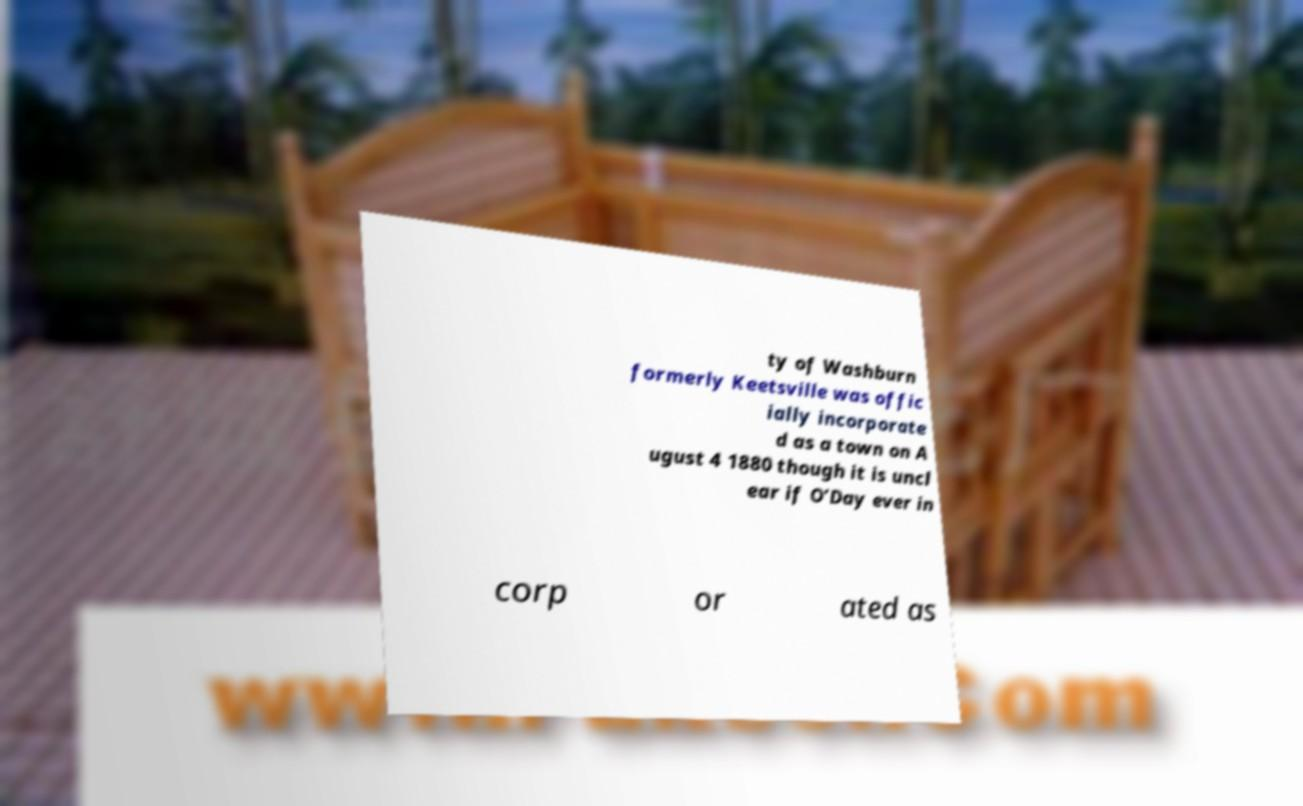Could you extract and type out the text from this image? ty of Washburn formerly Keetsville was offic ially incorporate d as a town on A ugust 4 1880 though it is uncl ear if O’Day ever in corp or ated as 